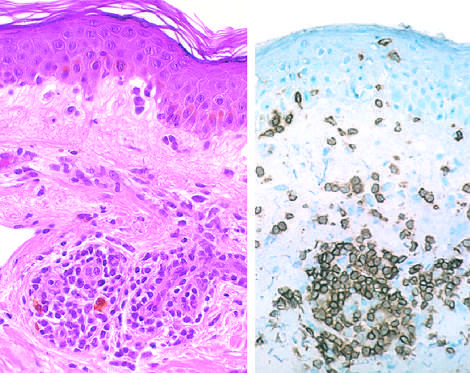what reveals a predominantly perivascular cellular infiltrate that marks positively with anti-cd4 antibodies?
Answer the question using a single word or phrase. Immunoperoxidase staining 